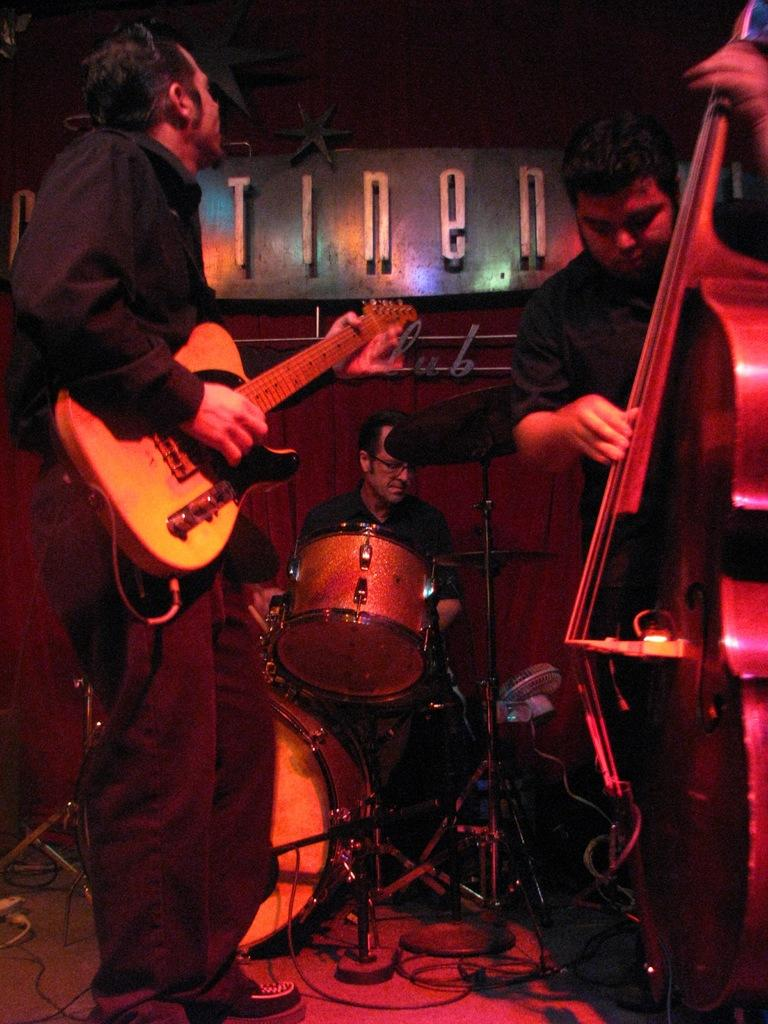How many people are in the image? There are people in the image, but the exact number is not specified. What are the people doing in the image? The people in the image are holding musical instruments. What type of magic is being performed by the people with the musical instruments in the image? There is no indication of magic or any magical performance in the image. The people are simply holding musical instruments. 